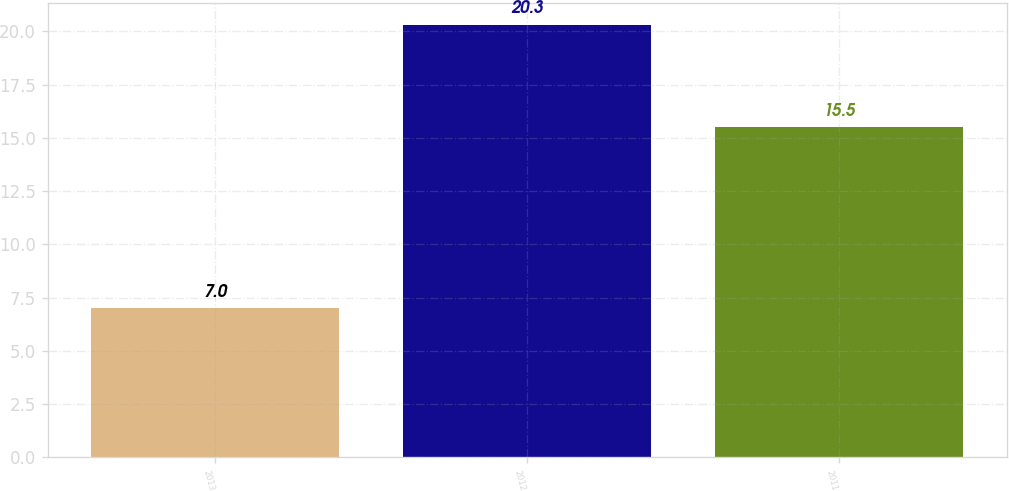Convert chart. <chart><loc_0><loc_0><loc_500><loc_500><bar_chart><fcel>2013<fcel>2012<fcel>2011<nl><fcel>7<fcel>20.3<fcel>15.5<nl></chart> 